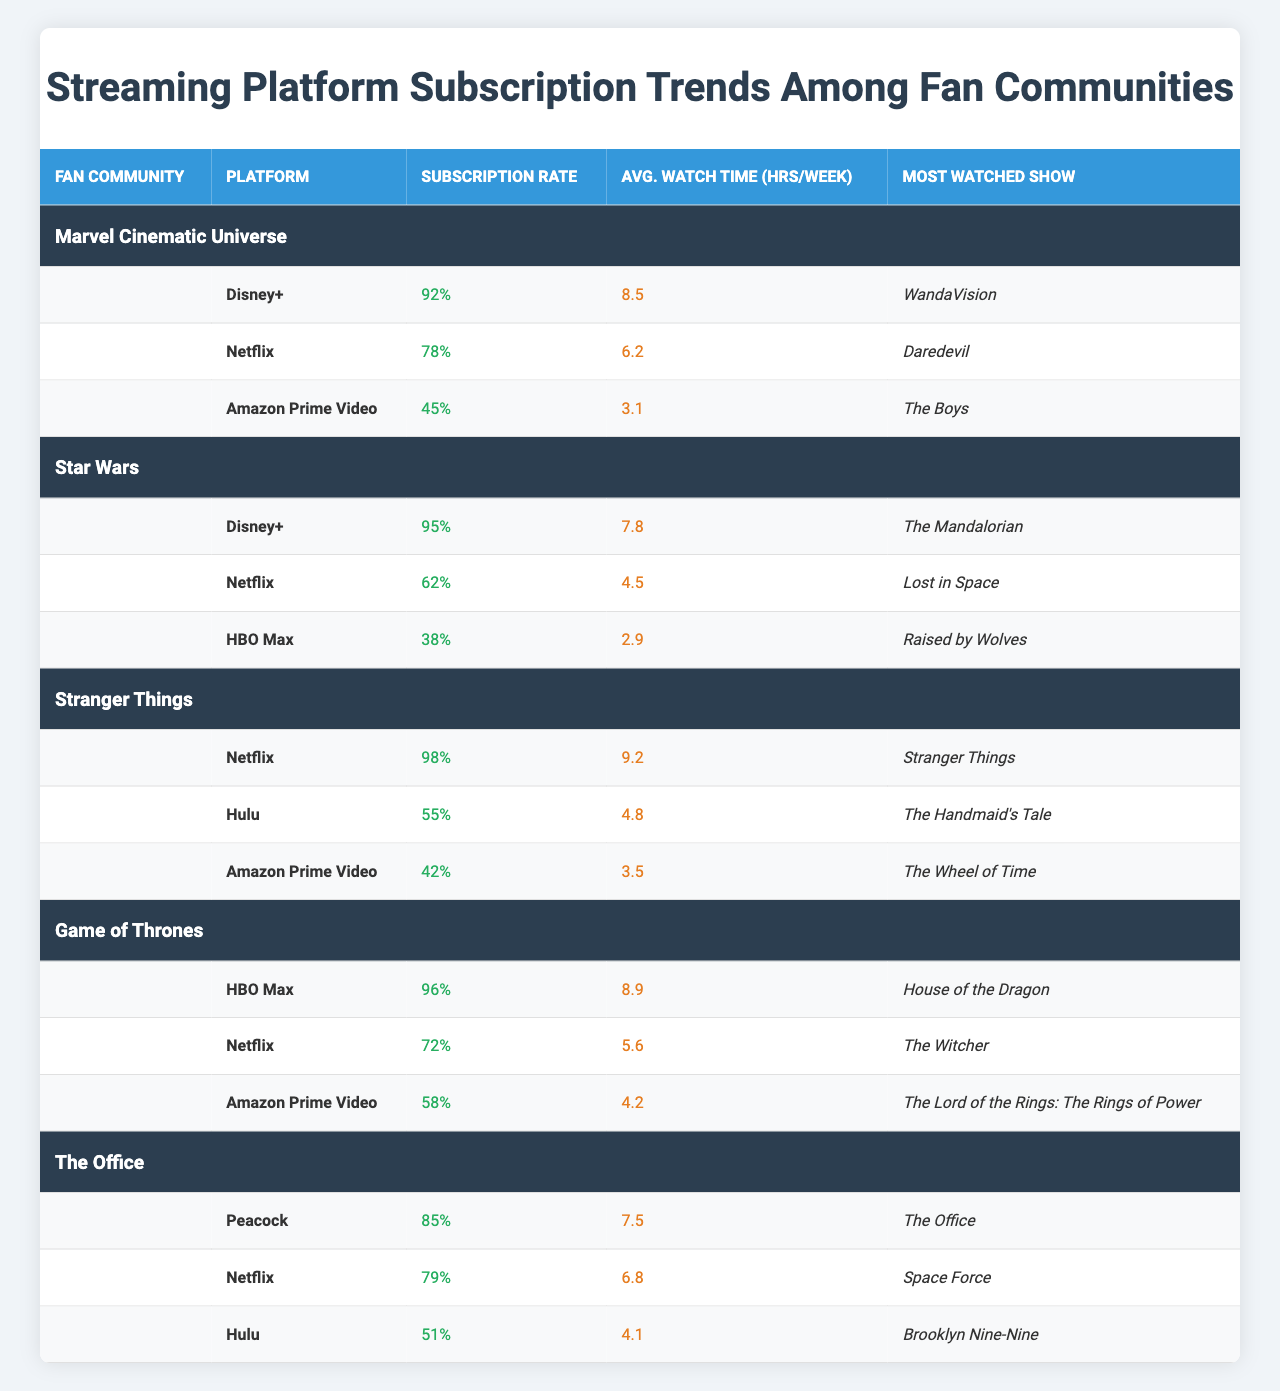What is the subscription rate for the Star Wars community on Disney+? The table shows that the subscription rate for the Star Wars community on Disney+ is listed as 95%.
Answer: 95% Which community has the highest average watch time on Netflix? The Stranger Things community has the highest average watch time on Netflix, at 9.2 hours per week.
Answer: Stranger Things What is the most watched show for fans of the Game of Thrones community on HBO Max? According to the table, the most watched show for the Game of Thrones community on HBO Max is "House of the Dragon."
Answer: House of the Dragon Which platform has the lowest subscription rate among fans of the Marvel Cinematic Universe? The platform with the lowest subscription rate among the Marvel Cinematic Universe fans is Amazon Prime Video, with a subscription rate of 45%.
Answer: Amazon Prime Video Calculate the total subscription rate for platforms used by the Stranger Things community. The total subscription rate for Stranger Things is obtained by adding the subscription rates: 98% (Netflix) + 55% (Hulu) + 42% (Amazon Prime) = 195%.
Answer: 195% Is there a platform where the subscription rate is below 40% for any fan community? Yes, HBO Max has a subscription rate of 38% among the Star Wars community.
Answer: Yes Which fan community has the highest average watch time across all platforms? To find the highest average watch time, we compare the average watch times: Marvel Cinematic Universe (8.5), Star Wars (7.8), Stranger Things (9.2), Game of Thrones (8.9), The Office (7.5); hence, Stranger Things has the highest average watch time at 9.2 hours per week.
Answer: Stranger Things What is the average subscription rate for Netflix among all communities listed? The average subscription rate for Netflix is computed as follows: (78 + 62 + 98 + 72 + 79) / 5 = 77.8%.
Answer: 77.8% Which community predominantly favors Hulu based on subscription rates? By examining the subscription rates, the Stranger Things community shows the most significant preference for Hulu with a 55% subscription rate.
Answer: Stranger Things Determine if the Marvel Cinematic Universe fans watch more hours per week on average compared to Star Wars fans on Disney+. Marvel fans watch an average of 8.5 hours per week on Disney+ while Star Wars fans watch an average of 7.8 hours, indicating Marvel fans watch more.
Answer: Yes 